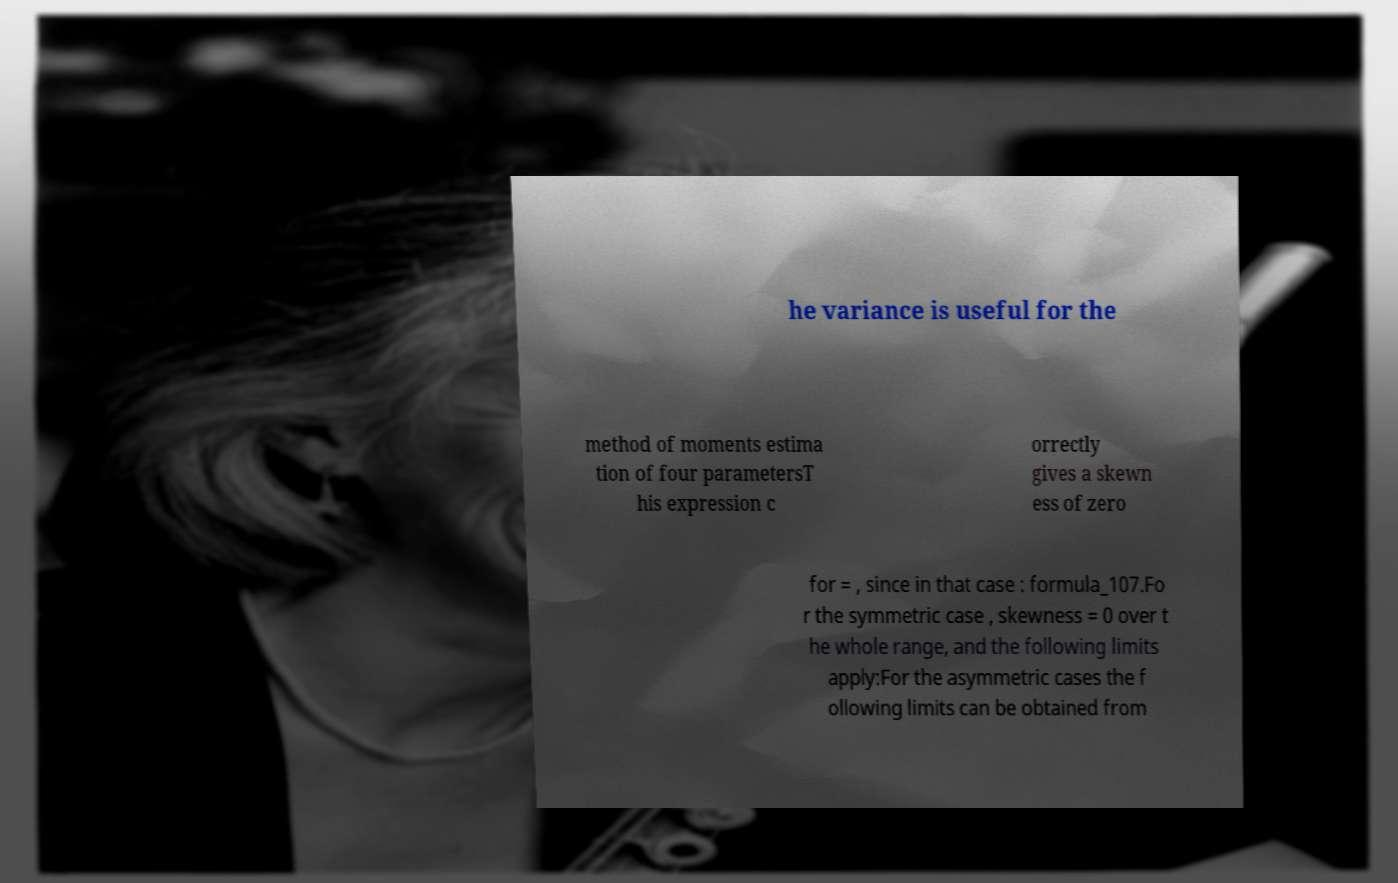Could you extract and type out the text from this image? he variance is useful for the method of moments estima tion of four parametersT his expression c orrectly gives a skewn ess of zero for = , since in that case : formula_107.Fo r the symmetric case , skewness = 0 over t he whole range, and the following limits apply:For the asymmetric cases the f ollowing limits can be obtained from 